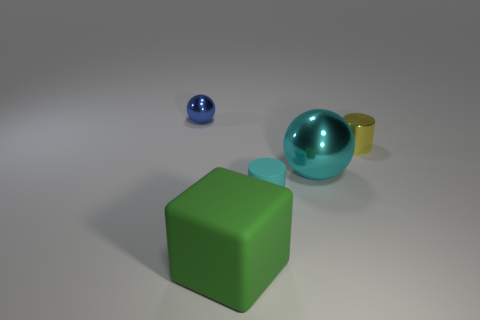Add 2 big things. How many objects exist? 7 Subtract all cyan spheres. How many spheres are left? 1 Subtract all cylinders. How many objects are left? 3 Add 4 small matte cylinders. How many small matte cylinders are left? 5 Add 4 cyan metal objects. How many cyan metal objects exist? 5 Subtract 1 green blocks. How many objects are left? 4 Subtract 1 blocks. How many blocks are left? 0 Subtract all gray spheres. Subtract all brown cubes. How many spheres are left? 2 Subtract all tiny blue cubes. Subtract all large cyan objects. How many objects are left? 4 